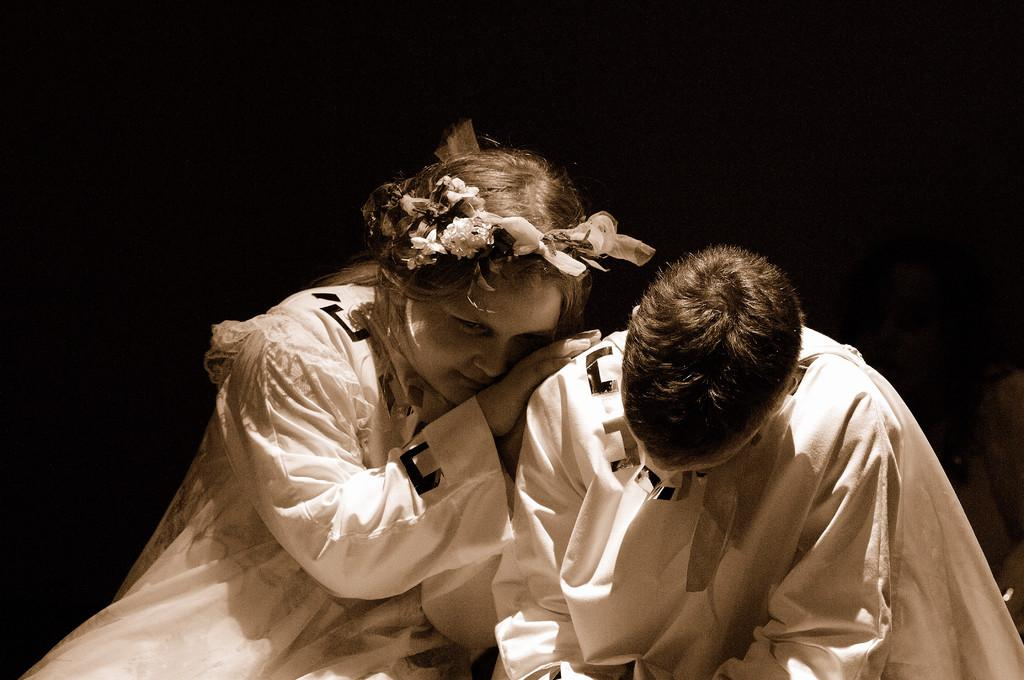How many people are in the image? There are two persons in the image. What is unique about the appearance of one of the persons? One of the persons is wearing a tiara. What can be observed about the lighting or color of the background in the image? The background of the image is dark. What type of curve can be seen on the stem of the cracker in the image? There is no cracker or curve present in the image. 